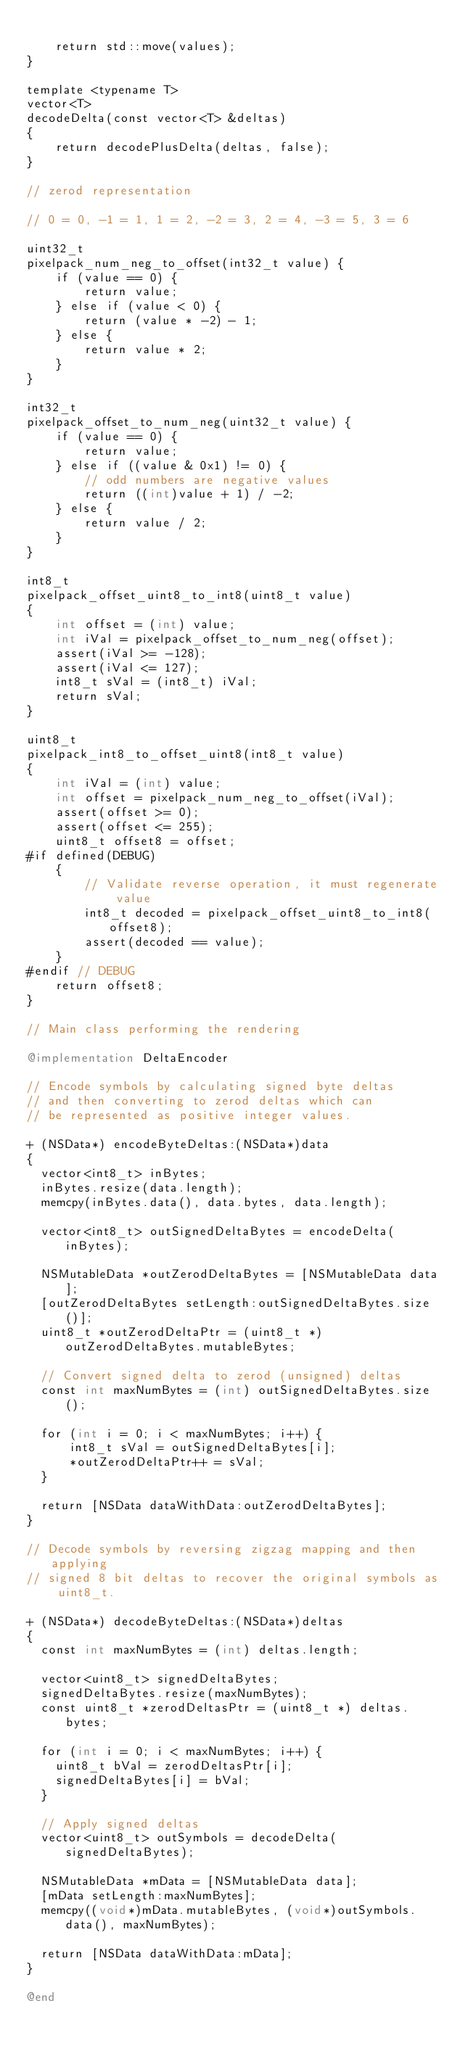Convert code to text. <code><loc_0><loc_0><loc_500><loc_500><_ObjectiveC_>    
    return std::move(values);
}

template <typename T>
vector<T>
decodeDelta(const vector<T> &deltas)
{
    return decodePlusDelta(deltas, false);
}

// zerod representation

// 0 = 0, -1 = 1, 1 = 2, -2 = 3, 2 = 4, -3 = 5, 3 = 6

uint32_t
pixelpack_num_neg_to_offset(int32_t value) {
    if (value == 0) {
        return value;
    } else if (value < 0) {
        return (value * -2) - 1;
    } else {
        return value * 2;
    }
}

int32_t
pixelpack_offset_to_num_neg(uint32_t value) {
    if (value == 0) {
        return value;
    } else if ((value & 0x1) != 0) {
        // odd numbers are negative values
        return ((int)value + 1) / -2;
    } else {
        return value / 2;
    }
}

int8_t
pixelpack_offset_uint8_to_int8(uint8_t value)
{
    int offset = (int) value;
    int iVal = pixelpack_offset_to_num_neg(offset);
    assert(iVal >= -128);
    assert(iVal <= 127);
    int8_t sVal = (int8_t) iVal;
    return sVal;
}

uint8_t
pixelpack_int8_to_offset_uint8(int8_t value)
{
    int iVal = (int) value;
    int offset = pixelpack_num_neg_to_offset(iVal);
    assert(offset >= 0);
    assert(offset <= 255);
    uint8_t offset8 = offset;
#if defined(DEBUG)
    {
        // Validate reverse operation, it must regenerate value
        int8_t decoded = pixelpack_offset_uint8_to_int8(offset8);
        assert(decoded == value);
    }
#endif // DEBUG
    return offset8;
}

// Main class performing the rendering

@implementation DeltaEncoder

// Encode symbols by calculating signed byte deltas
// and then converting to zerod deltas which can
// be represented as positive integer values.

+ (NSData*) encodeByteDeltas:(NSData*)data
{
  vector<int8_t> inBytes;
  inBytes.resize(data.length);
  memcpy(inBytes.data(), data.bytes, data.length);
  
  vector<int8_t> outSignedDeltaBytes = encodeDelta(inBytes);
    
  NSMutableData *outZerodDeltaBytes = [NSMutableData data];
  [outZerodDeltaBytes setLength:outSignedDeltaBytes.size()];
  uint8_t *outZerodDeltaPtr = (uint8_t *) outZerodDeltaBytes.mutableBytes;
    
  // Convert signed delta to zerod (unsigned) deltas
  const int maxNumBytes = (int) outSignedDeltaBytes.size();

  for (int i = 0; i < maxNumBytes; i++) {
      int8_t sVal = outSignedDeltaBytes[i];
      *outZerodDeltaPtr++ = sVal;
  }

  return [NSData dataWithData:outZerodDeltaBytes];
}

// Decode symbols by reversing zigzag mapping and then applying
// signed 8 bit deltas to recover the original symbols as uint8_t.

+ (NSData*) decodeByteDeltas:(NSData*)deltas
{
  const int maxNumBytes = (int) deltas.length;

  vector<uint8_t> signedDeltaBytes;
  signedDeltaBytes.resize(maxNumBytes);
  const uint8_t *zerodDeltasPtr = (uint8_t *) deltas.bytes;
  
  for (int i = 0; i < maxNumBytes; i++) {
    uint8_t bVal = zerodDeltasPtr[i];
    signedDeltaBytes[i] = bVal;
  }

  // Apply signed deltas
  vector<uint8_t> outSymbols = decodeDelta(signedDeltaBytes);
    
  NSMutableData *mData = [NSMutableData data];
  [mData setLength:maxNumBytes];
  memcpy((void*)mData.mutableBytes, (void*)outSymbols.data(), maxNumBytes);
    
  return [NSData dataWithData:mData];
}

@end

</code> 